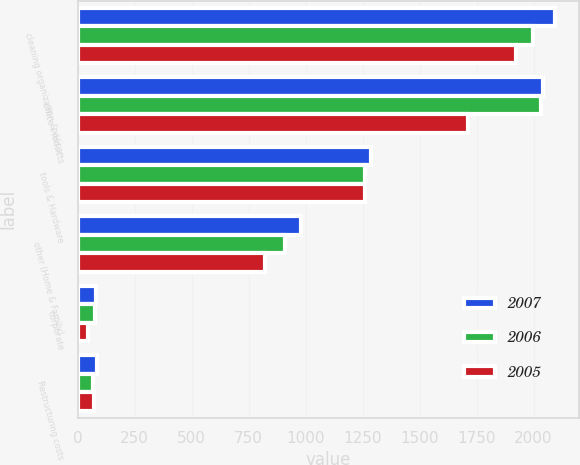Convert chart. <chart><loc_0><loc_0><loc_500><loc_500><stacked_bar_chart><ecel><fcel>cleaning organization & décor<fcel>office Products<fcel>tools & Hardware<fcel>other (Home & Family)<fcel>corporate<fcel>Restructuring costs<nl><fcel>2007<fcel>2096.4<fcel>2042.3<fcel>1288.7<fcel>979.9<fcel>82<fcel>86<nl><fcel>2006<fcel>1995.7<fcel>2031.6<fcel>1262.2<fcel>911.5<fcel>76<fcel>66.4<nl><fcel>2005<fcel>1921<fcel>1713.3<fcel>1260.3<fcel>822.6<fcel>46<fcel>72.6<nl></chart> 